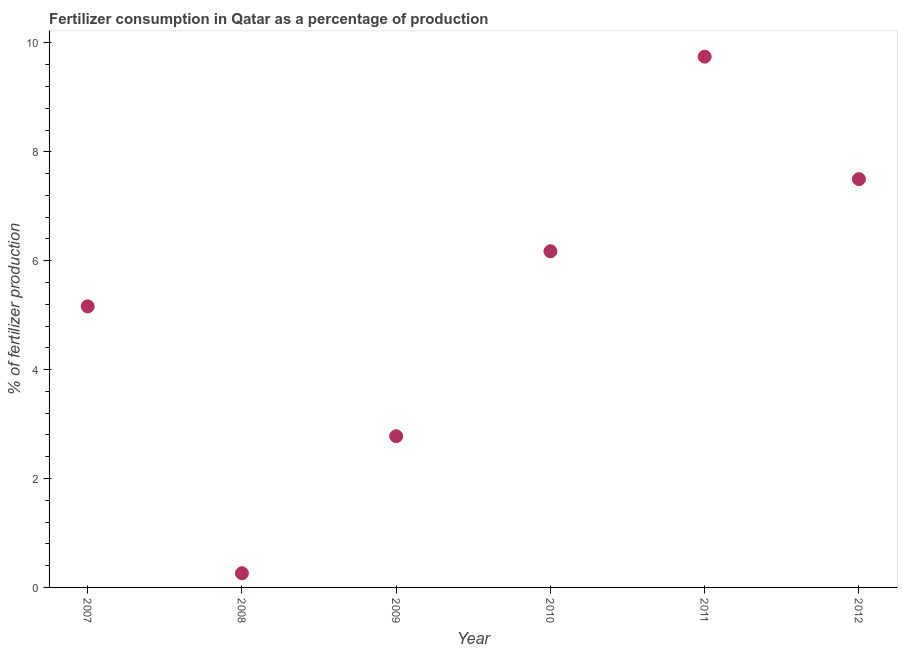What is the amount of fertilizer consumption in 2011?
Your answer should be compact. 9.75. Across all years, what is the maximum amount of fertilizer consumption?
Provide a succinct answer. 9.75. Across all years, what is the minimum amount of fertilizer consumption?
Offer a terse response. 0.26. In which year was the amount of fertilizer consumption maximum?
Keep it short and to the point. 2011. In which year was the amount of fertilizer consumption minimum?
Your answer should be compact. 2008. What is the sum of the amount of fertilizer consumption?
Offer a very short reply. 31.62. What is the difference between the amount of fertilizer consumption in 2008 and 2009?
Keep it short and to the point. -2.52. What is the average amount of fertilizer consumption per year?
Your response must be concise. 5.27. What is the median amount of fertilizer consumption?
Your answer should be very brief. 5.67. What is the ratio of the amount of fertilizer consumption in 2007 to that in 2012?
Keep it short and to the point. 0.69. Is the difference between the amount of fertilizer consumption in 2009 and 2011 greater than the difference between any two years?
Give a very brief answer. No. What is the difference between the highest and the second highest amount of fertilizer consumption?
Offer a very short reply. 2.25. Is the sum of the amount of fertilizer consumption in 2009 and 2011 greater than the maximum amount of fertilizer consumption across all years?
Offer a very short reply. Yes. What is the difference between the highest and the lowest amount of fertilizer consumption?
Make the answer very short. 9.49. Does the amount of fertilizer consumption monotonically increase over the years?
Keep it short and to the point. No. How many years are there in the graph?
Your response must be concise. 6. What is the difference between two consecutive major ticks on the Y-axis?
Give a very brief answer. 2. Are the values on the major ticks of Y-axis written in scientific E-notation?
Provide a succinct answer. No. Does the graph contain any zero values?
Offer a very short reply. No. Does the graph contain grids?
Your answer should be very brief. No. What is the title of the graph?
Your answer should be compact. Fertilizer consumption in Qatar as a percentage of production. What is the label or title of the Y-axis?
Offer a very short reply. % of fertilizer production. What is the % of fertilizer production in 2007?
Offer a terse response. 5.16. What is the % of fertilizer production in 2008?
Keep it short and to the point. 0.26. What is the % of fertilizer production in 2009?
Offer a very short reply. 2.78. What is the % of fertilizer production in 2010?
Offer a very short reply. 6.17. What is the % of fertilizer production in 2011?
Make the answer very short. 9.75. What is the % of fertilizer production in 2012?
Offer a very short reply. 7.5. What is the difference between the % of fertilizer production in 2007 and 2008?
Your answer should be very brief. 4.9. What is the difference between the % of fertilizer production in 2007 and 2009?
Keep it short and to the point. 2.38. What is the difference between the % of fertilizer production in 2007 and 2010?
Provide a short and direct response. -1.01. What is the difference between the % of fertilizer production in 2007 and 2011?
Your answer should be compact. -4.59. What is the difference between the % of fertilizer production in 2007 and 2012?
Make the answer very short. -2.34. What is the difference between the % of fertilizer production in 2008 and 2009?
Offer a very short reply. -2.52. What is the difference between the % of fertilizer production in 2008 and 2010?
Your answer should be compact. -5.91. What is the difference between the % of fertilizer production in 2008 and 2011?
Make the answer very short. -9.49. What is the difference between the % of fertilizer production in 2008 and 2012?
Your answer should be very brief. -7.24. What is the difference between the % of fertilizer production in 2009 and 2010?
Provide a short and direct response. -3.4. What is the difference between the % of fertilizer production in 2009 and 2011?
Ensure brevity in your answer.  -6.97. What is the difference between the % of fertilizer production in 2009 and 2012?
Your answer should be compact. -4.72. What is the difference between the % of fertilizer production in 2010 and 2011?
Give a very brief answer. -3.57. What is the difference between the % of fertilizer production in 2010 and 2012?
Provide a succinct answer. -1.33. What is the difference between the % of fertilizer production in 2011 and 2012?
Your answer should be compact. 2.25. What is the ratio of the % of fertilizer production in 2007 to that in 2008?
Ensure brevity in your answer.  19.77. What is the ratio of the % of fertilizer production in 2007 to that in 2009?
Make the answer very short. 1.86. What is the ratio of the % of fertilizer production in 2007 to that in 2010?
Keep it short and to the point. 0.84. What is the ratio of the % of fertilizer production in 2007 to that in 2011?
Your answer should be very brief. 0.53. What is the ratio of the % of fertilizer production in 2007 to that in 2012?
Offer a very short reply. 0.69. What is the ratio of the % of fertilizer production in 2008 to that in 2009?
Offer a terse response. 0.09. What is the ratio of the % of fertilizer production in 2008 to that in 2010?
Keep it short and to the point. 0.04. What is the ratio of the % of fertilizer production in 2008 to that in 2011?
Your answer should be compact. 0.03. What is the ratio of the % of fertilizer production in 2008 to that in 2012?
Your answer should be compact. 0.04. What is the ratio of the % of fertilizer production in 2009 to that in 2010?
Keep it short and to the point. 0.45. What is the ratio of the % of fertilizer production in 2009 to that in 2011?
Offer a very short reply. 0.28. What is the ratio of the % of fertilizer production in 2009 to that in 2012?
Give a very brief answer. 0.37. What is the ratio of the % of fertilizer production in 2010 to that in 2011?
Keep it short and to the point. 0.63. What is the ratio of the % of fertilizer production in 2010 to that in 2012?
Your response must be concise. 0.82. 